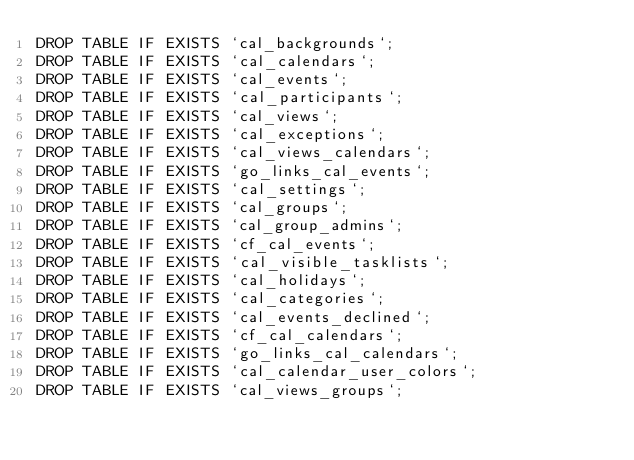Convert code to text. <code><loc_0><loc_0><loc_500><loc_500><_SQL_>DROP TABLE IF EXISTS `cal_backgrounds`;
DROP TABLE IF EXISTS `cal_calendars`;
DROP TABLE IF EXISTS `cal_events`;
DROP TABLE IF EXISTS `cal_participants`;
DROP TABLE IF EXISTS `cal_views`;
DROP TABLE IF EXISTS `cal_exceptions`;
DROP TABLE IF EXISTS `cal_views_calendars`;
DROP TABLE IF EXISTS `go_links_cal_events`;
DROP TABLE IF EXISTS `cal_settings`;
DROP TABLE IF EXISTS `cal_groups`;
DROP TABLE IF EXISTS `cal_group_admins`;
DROP TABLE IF EXISTS `cf_cal_events`;
DROP TABLE IF EXISTS `cal_visible_tasklists`;
DROP TABLE IF EXISTS `cal_holidays`;
DROP TABLE IF EXISTS `cal_categories`;
DROP TABLE IF EXISTS `cal_events_declined`;
DROP TABLE IF EXISTS `cf_cal_calendars`;
DROP TABLE IF EXISTS `go_links_cal_calendars`;
DROP TABLE IF EXISTS `cal_calendar_user_colors`;
DROP TABLE IF EXISTS `cal_views_groups`;</code> 